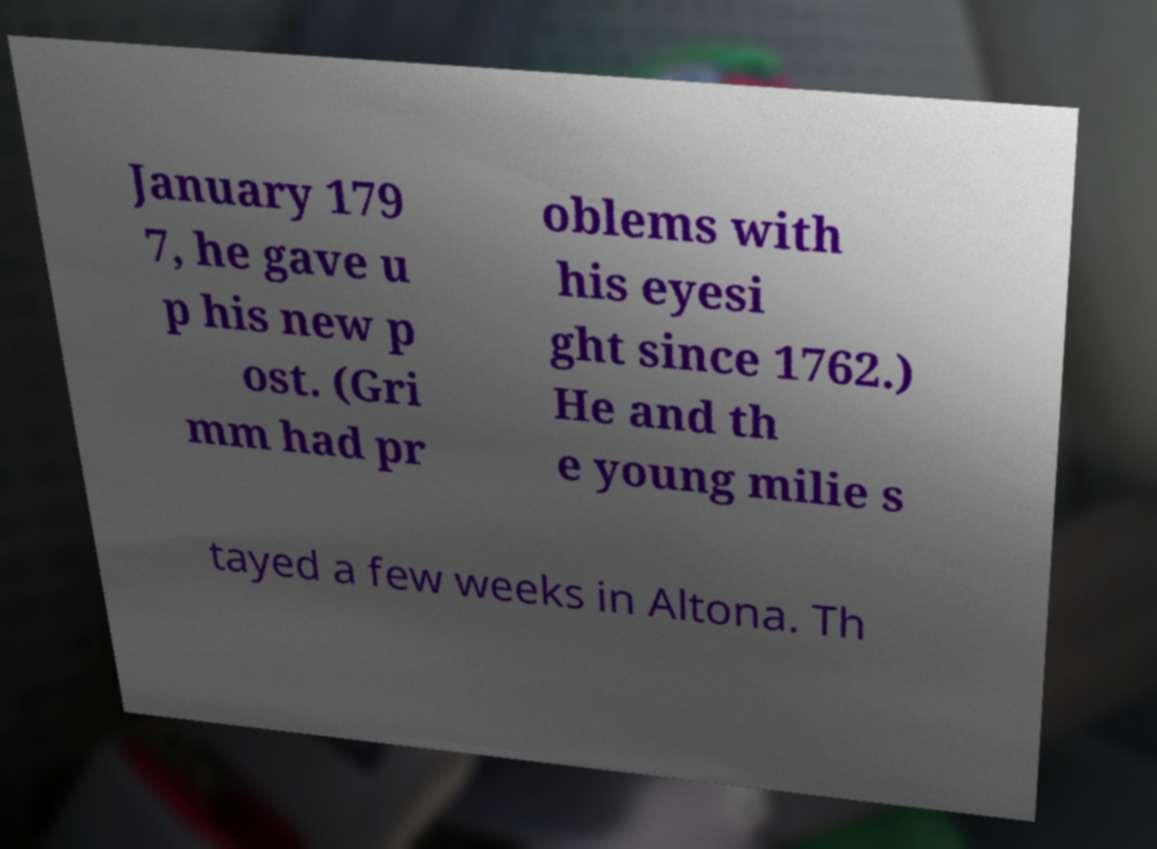Please read and relay the text visible in this image. What does it say? January 179 7, he gave u p his new p ost. (Gri mm had pr oblems with his eyesi ght since 1762.) He and th e young milie s tayed a few weeks in Altona. Th 